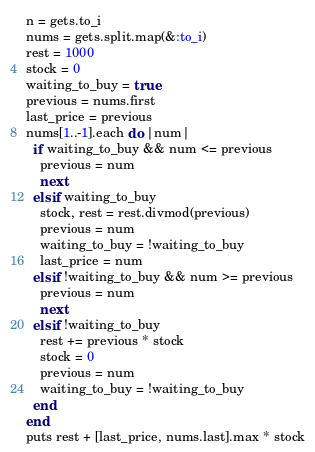<code> <loc_0><loc_0><loc_500><loc_500><_Ruby_>n = gets.to_i
nums = gets.split.map(&:to_i)
rest = 1000
stock = 0
waiting_to_buy = true
previous = nums.first
last_price = previous
nums[1..-1].each do |num|
  if waiting_to_buy && num <= previous
    previous = num
    next
  elsif waiting_to_buy
    stock, rest = rest.divmod(previous)
    previous = num
    waiting_to_buy = !waiting_to_buy
    last_price = num
  elsif !waiting_to_buy && num >= previous
    previous = num
    next
  elsif !waiting_to_buy
    rest += previous * stock
    stock = 0
    previous = num
    waiting_to_buy = !waiting_to_buy
  end
end
puts rest + [last_price, nums.last].max * stock
</code> 